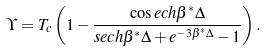Convert formula to latex. <formula><loc_0><loc_0><loc_500><loc_500>\Upsilon = T _ { c } \left ( 1 - \frac { \cos e c h \beta ^ { * } \Delta } { s e c h \beta ^ { * } \Delta + e ^ { - 3 \beta ^ { * } \Delta } - 1 } \right ) .</formula> 